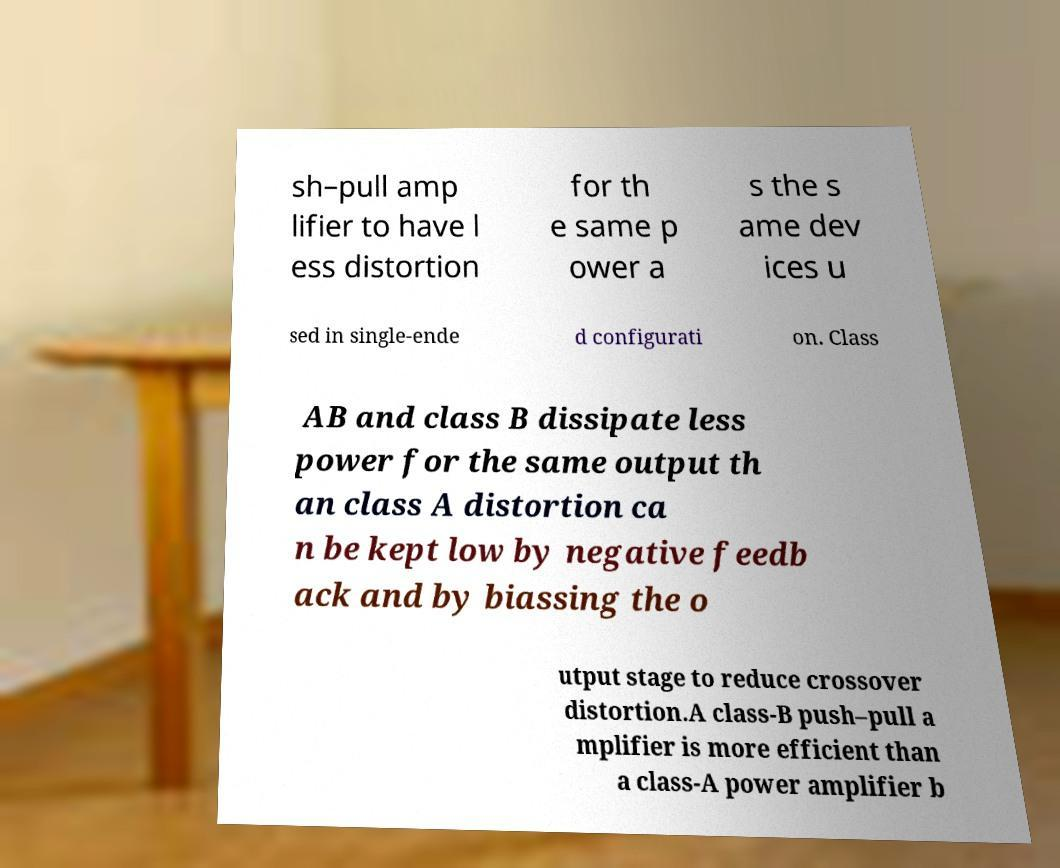Could you extract and type out the text from this image? sh–pull amp lifier to have l ess distortion for th e same p ower a s the s ame dev ices u sed in single-ende d configurati on. Class AB and class B dissipate less power for the same output th an class A distortion ca n be kept low by negative feedb ack and by biassing the o utput stage to reduce crossover distortion.A class-B push–pull a mplifier is more efficient than a class-A power amplifier b 